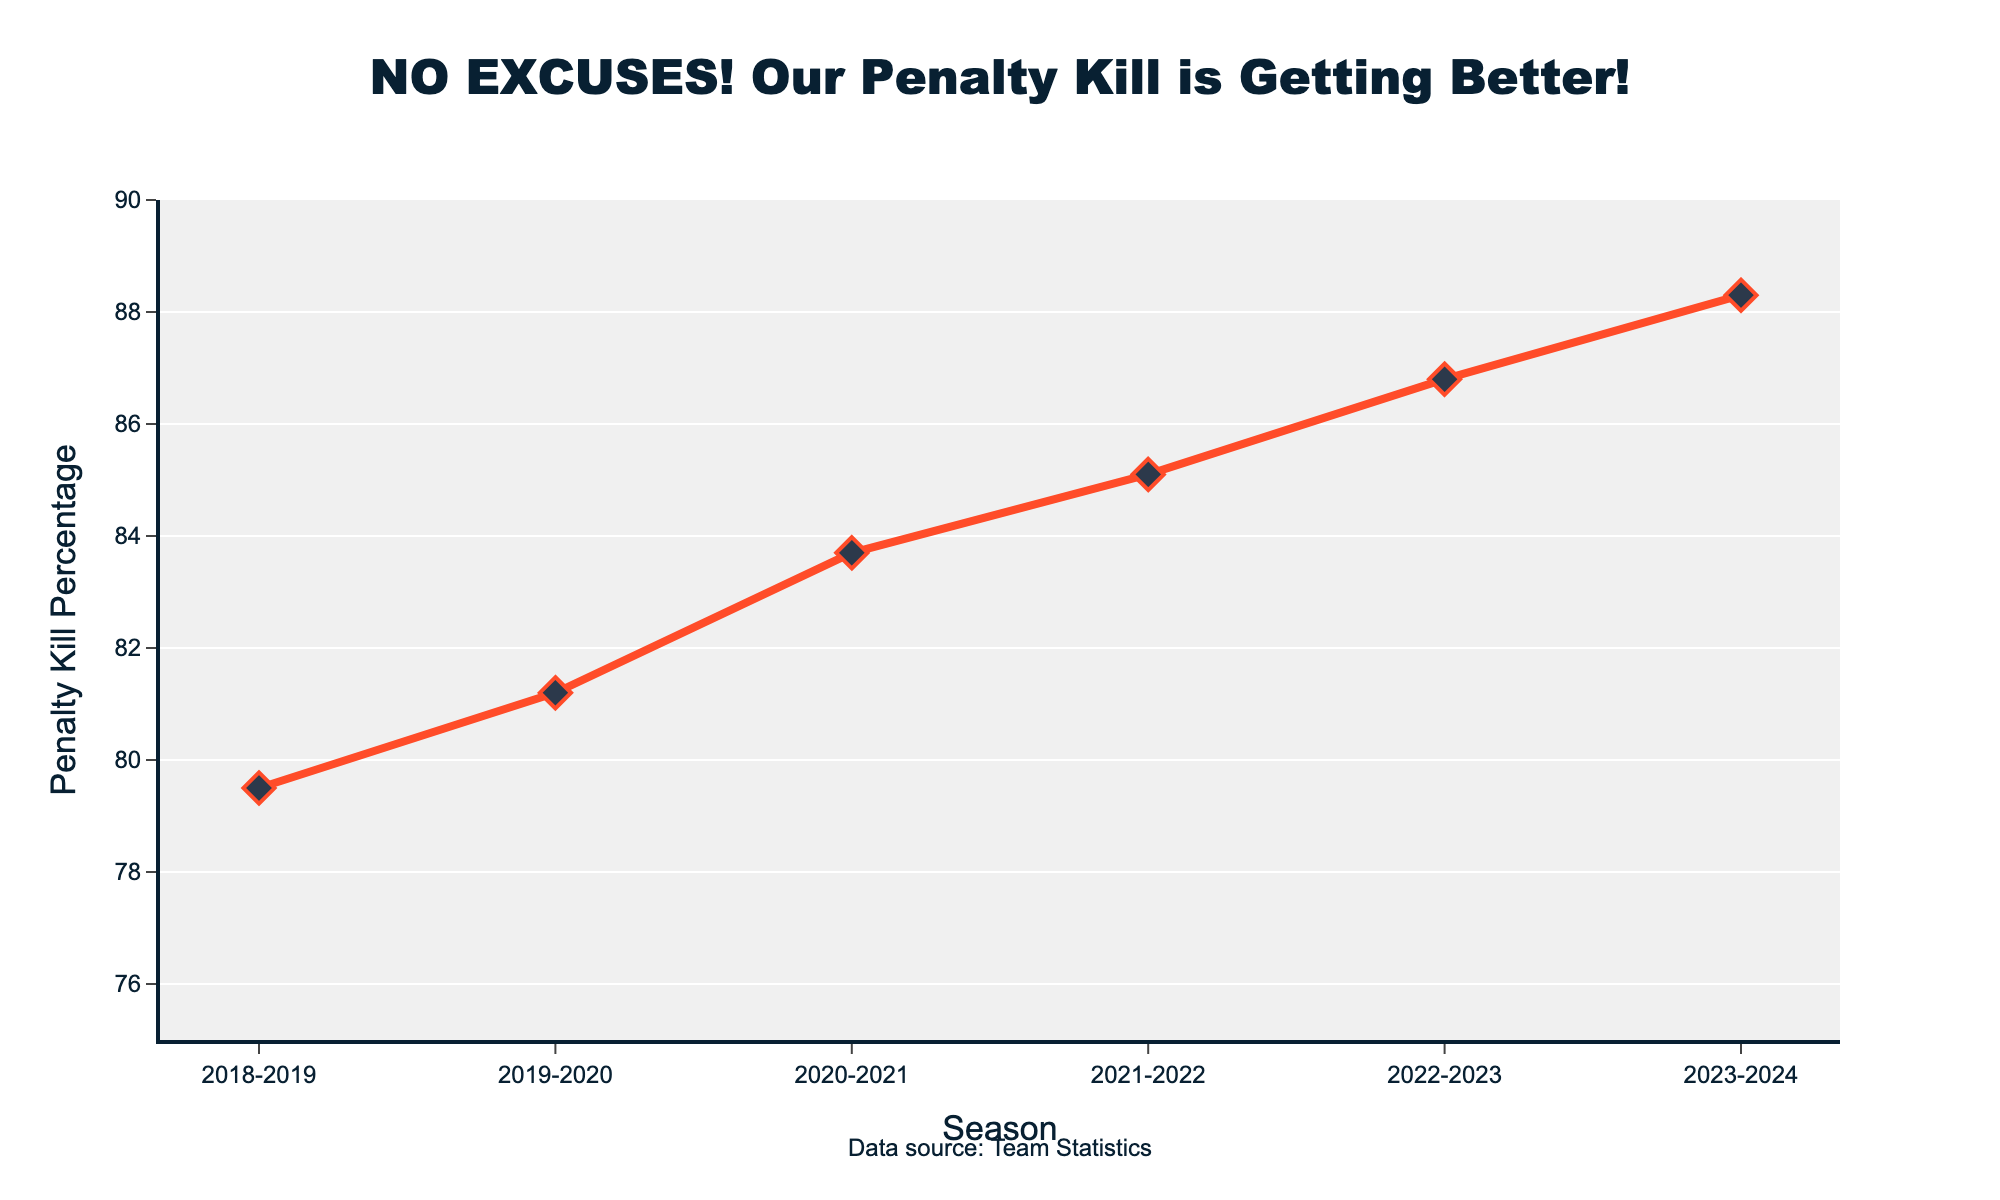What is the penalty kill percentage in the 2022-2023 season? The penalty kill percentage for each season is marked on the x-axis, and the values are on the y-axis. For the 2022-2023 season, the penalty kill percentage is marked as 86.8%.
Answer: 86.8% How does the penalty kill percentage in the 2023-2024 season compare to the 2018-2019 season? We compare the penalty kill percentages of the two seasons. The 2018-2019 season has a percentage of 79.5%, and the 2023-2024 season has 88.3%. The difference is 88.3 - 79.5 = 8.8%.
Answer: 8.8% higher By how much did the penalty kill percentage improve on average per season over the given period? To calculate the average improvement per season, first determine the total improvement by subtracting the initial season's percentage from the final season's percentage: 88.3 - 79.5 = 8.8%. The given period covers 5 intervals (from 2018-2019 to 2023-2024), so the average improvement per season is 8.8% / 5 = 1.76%.
Answer: 1.76% What is the general trend observed in the penalty kill percentage over these seasons? By observing the plot, we see that the penalty kill percentage consistently increases each season from 79.5% in 2018-2019 to 88.3% in 2023-2024. This indicates a continuously improving trend in the team's penalty kill percentage.
Answer: Increasing trend 